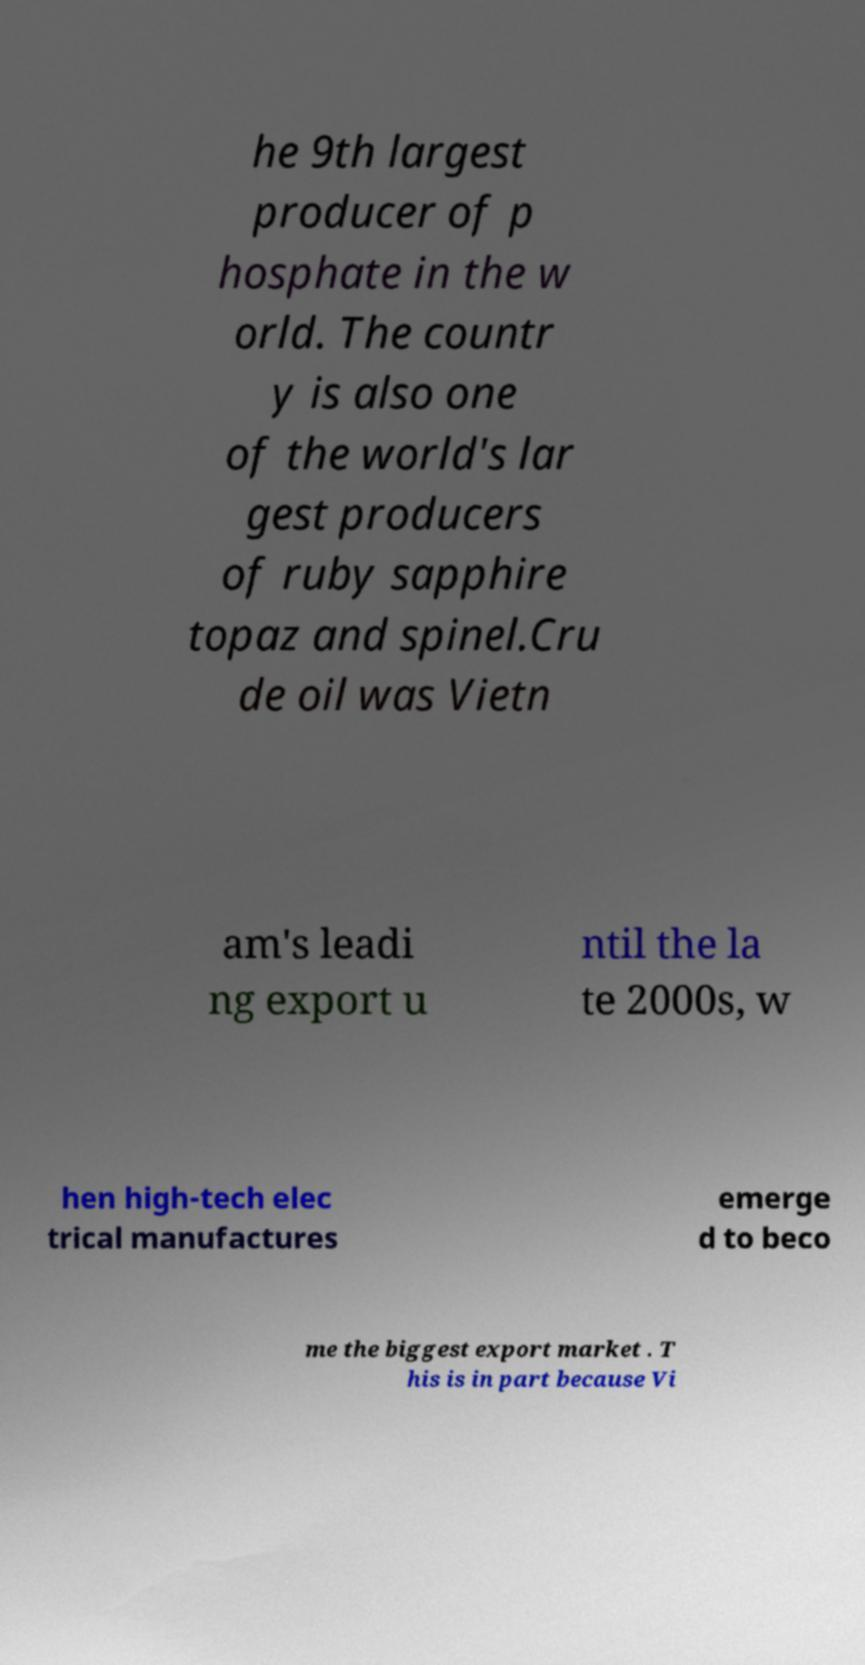Can you read and provide the text displayed in the image?This photo seems to have some interesting text. Can you extract and type it out for me? he 9th largest producer of p hosphate in the w orld. The countr y is also one of the world's lar gest producers of ruby sapphire topaz and spinel.Cru de oil was Vietn am's leadi ng export u ntil the la te 2000s, w hen high-tech elec trical manufactures emerge d to beco me the biggest export market . T his is in part because Vi 